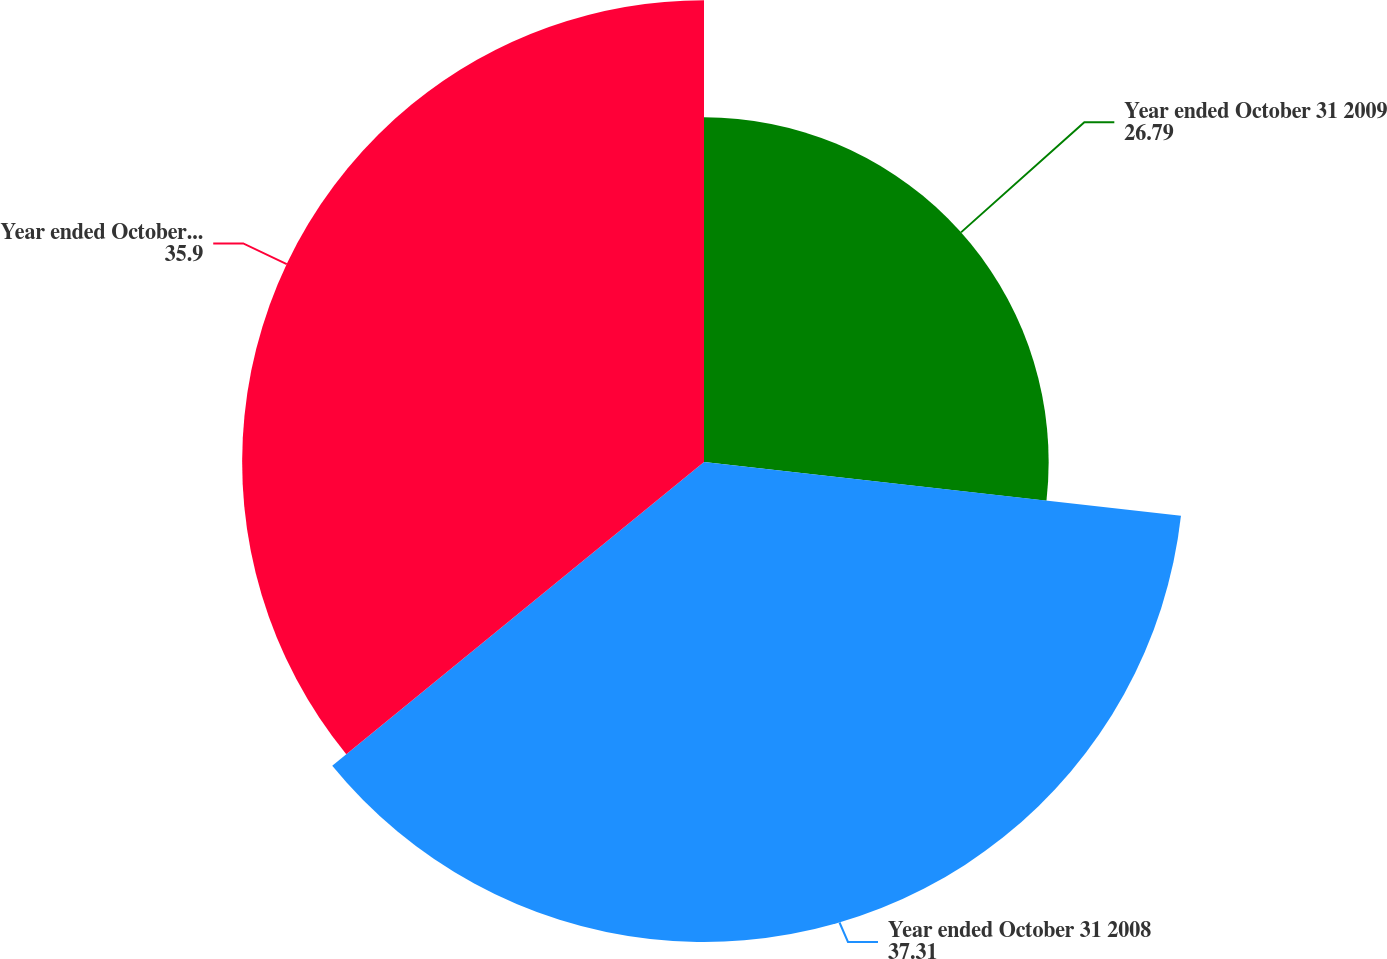Convert chart. <chart><loc_0><loc_0><loc_500><loc_500><pie_chart><fcel>Year ended October 31 2009<fcel>Year ended October 31 2008<fcel>Year ended October 31 2007<nl><fcel>26.79%<fcel>37.31%<fcel>35.9%<nl></chart> 